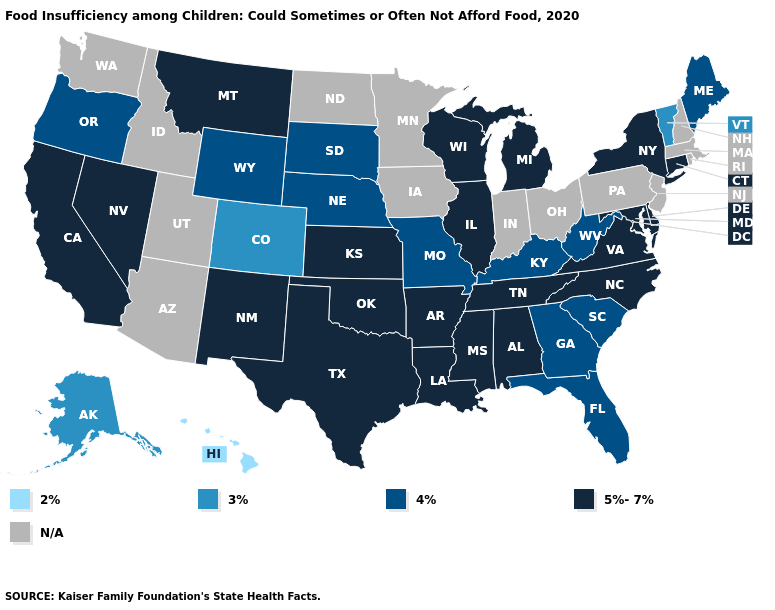Which states hav the highest value in the South?
Give a very brief answer. Alabama, Arkansas, Delaware, Louisiana, Maryland, Mississippi, North Carolina, Oklahoma, Tennessee, Texas, Virginia. Name the states that have a value in the range 3%?
Give a very brief answer. Alaska, Colorado, Vermont. Among the states that border Florida , does Georgia have the highest value?
Keep it brief. No. Does Wisconsin have the lowest value in the MidWest?
Be succinct. No. Which states have the lowest value in the USA?
Be succinct. Hawaii. Is the legend a continuous bar?
Answer briefly. No. How many symbols are there in the legend?
Answer briefly. 5. What is the lowest value in states that border Delaware?
Short answer required. 5%-7%. Name the states that have a value in the range 3%?
Write a very short answer. Alaska, Colorado, Vermont. Among the states that border Kentucky , which have the lowest value?
Be succinct. Missouri, West Virginia. What is the value of Missouri?
Quick response, please. 4%. Among the states that border Texas , which have the lowest value?
Answer briefly. Arkansas, Louisiana, New Mexico, Oklahoma. What is the lowest value in the USA?
Quick response, please. 2%. What is the value of Ohio?
Be succinct. N/A. 